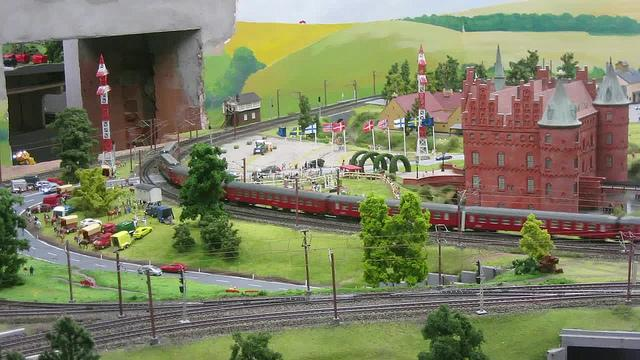Why does the background seem so flat and odd what type train scene does this signify that this is? miniature 